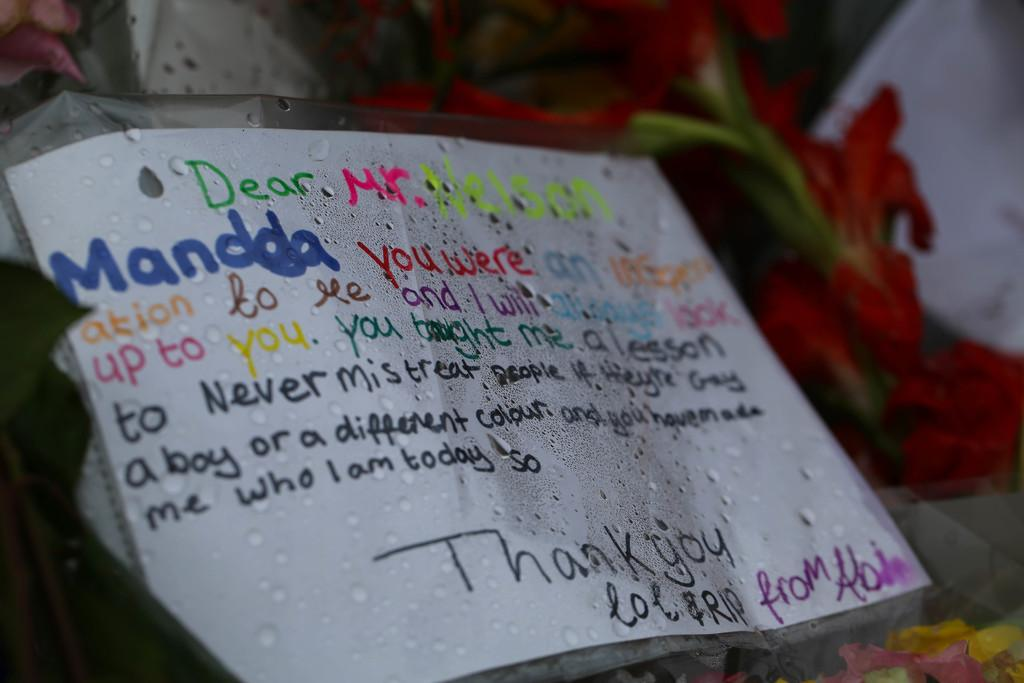What is the main subject in the middle of the image? There is a poster in the middle of the image. What can be found on the poster? The poster has texts. How are the texts on the poster differentiated? The texts on the poster are in different colors. Can you describe the overall appearance of the image? The background of the image is blurred. How many ants can be seen crawling on the poster in the image? There are no ants present on the poster or in the image. What type of van is parked next to the poster in the image? There is no van present in the image; it only features a poster with texts. 